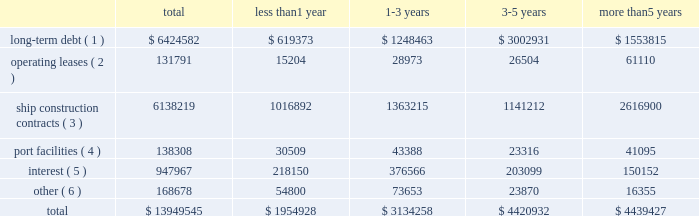Off-balance sheet transactions contractual obligations as of december 31 , 2017 , our contractual obligations with initial or remaining terms in excess of one year , including interest payments on long-term debt obligations , were as follows ( in thousands ) : the table above does not include $ 0.5 million of unrecognized tax benefits ( we refer you to the notes to the consolidated financial statements note 201410 201cincome tax 201d ) .
Certain service providers may require collateral in the normal course of our business .
The amount of collateral may change based on certain terms and conditions .
As a routine part of our business , depending on market conditions , exchange rates , pricing and our strategy for growth , we regularly consider opportunities to enter into contracts for the building of additional ships .
We may also consider the sale of ships , potential acquisitions and strategic alliances .
If any of these transactions were to occur , they may be financed through the incurrence of additional permitted indebtedness , through cash flows from operations , or through the issuance of debt , equity or equity-related securities .
Funding sources certain of our debt agreements contain covenants that , among other things , require us to maintain a minimum level of liquidity , as well as limit our net funded debt-to-capital ratio , maintain certain other ratios and restrict our ability to pay dividends .
Substantially all of our ships and other property and equipment are pledged as collateral for certain of our debt .
We believe we were in compliance with these covenants as of december 31 , 2017 .
The impact of changes in world economies and especially the global credit markets can create a challenging environment and may reduce future consumer demand for cruises and adversely affect our counterparty credit risks .
In the event this environment deteriorates , our business , financial condition and results of operations could be adversely impacted .
We believe our cash on hand , expected future operating cash inflows , additional available borrowings under our new revolving loan facility and our ability to issue debt securities or additional equity securities , will be sufficient to fund operations , debt payment requirements , capital expenditures and maintain compliance with covenants under our debt agreements over the next twelve-month period .
There is no assurance that cash flows from operations and additional financings will be available in the future to fund our future obligations .
Less than 1 year 1-3 years 3-5 years more than 5 years long-term debt ( 1 ) $ 6424582 $ 619373 $ 1248463 $ 3002931 $ 1553815 operating leases ( 2 ) 131791 15204 28973 26504 61110 ship construction contracts ( 3 ) 6138219 1016892 1363215 1141212 2616900 port facilities ( 4 ) 138308 30509 43388 23316 41095 interest ( 5 ) 947967 218150 376566 203099 150152 other ( 6 ) 168678 54800 73653 23870 16355 .
( 1 ) includes discount and premiums aggregating $ 0.5 million .
Also includes capital leases .
The amount excludes deferred financing fees which are included in the consolidated balance sheets as an offset to long-term debt .
( 2 ) primarily for offices , motor vehicles and office equipment .
( 3 ) for our newbuild ships based on the euro/u.s .
Dollar exchange rate as of december 31 , 2017 .
Export credit financing is in place from syndicates of banks .
( 4 ) primarily for our usage of certain port facilities .
( 5 ) includes fixed and variable rates with libor held constant as of december 31 , 2017 .
( 6 ) future commitments for service , maintenance and other business enhancement capital expenditure contracts. .
What will be the balance of long-term debt after 1 year assuming that everything is paid as planned and no additional debt is raised? 
Computations: (6424582 - 619373)
Answer: 5805209.0. 